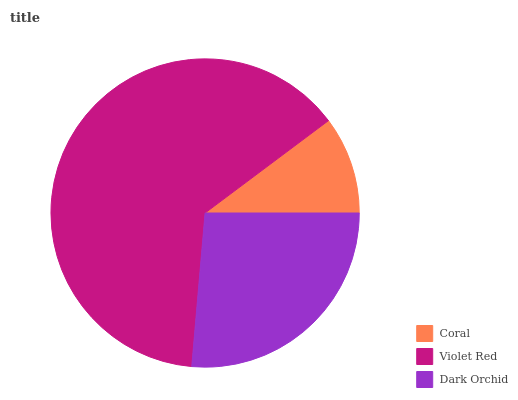Is Coral the minimum?
Answer yes or no. Yes. Is Violet Red the maximum?
Answer yes or no. Yes. Is Dark Orchid the minimum?
Answer yes or no. No. Is Dark Orchid the maximum?
Answer yes or no. No. Is Violet Red greater than Dark Orchid?
Answer yes or no. Yes. Is Dark Orchid less than Violet Red?
Answer yes or no. Yes. Is Dark Orchid greater than Violet Red?
Answer yes or no. No. Is Violet Red less than Dark Orchid?
Answer yes or no. No. Is Dark Orchid the high median?
Answer yes or no. Yes. Is Dark Orchid the low median?
Answer yes or no. Yes. Is Violet Red the high median?
Answer yes or no. No. Is Violet Red the low median?
Answer yes or no. No. 